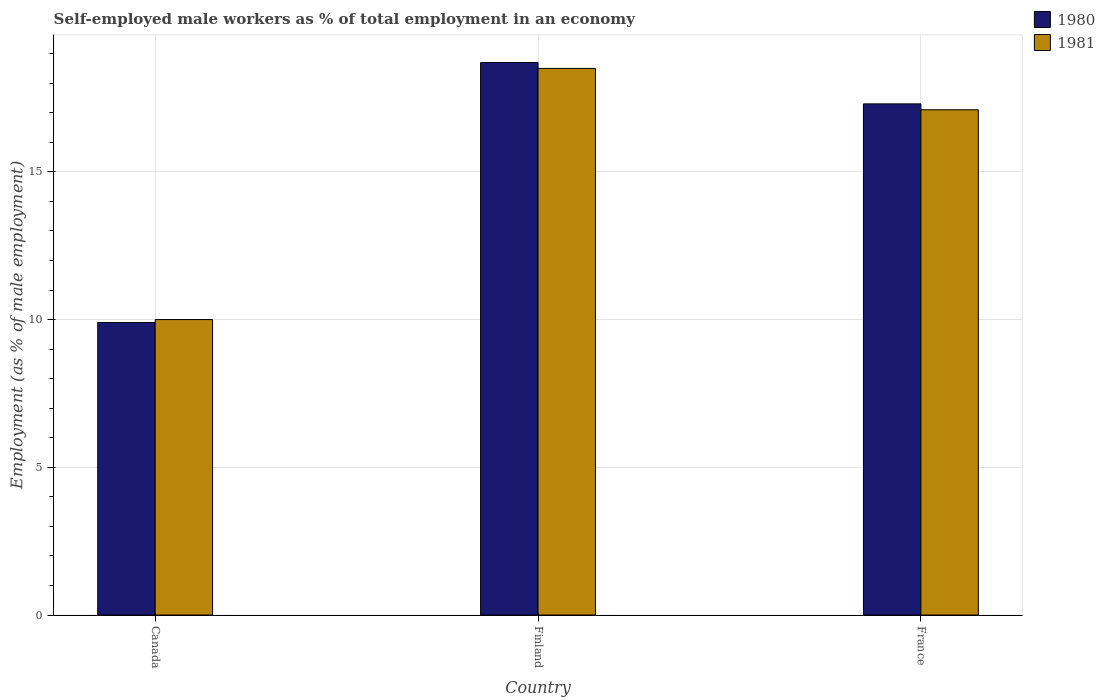How many groups of bars are there?
Make the answer very short. 3. Are the number of bars per tick equal to the number of legend labels?
Your response must be concise. Yes. Are the number of bars on each tick of the X-axis equal?
Your answer should be very brief. Yes. How many bars are there on the 2nd tick from the right?
Your answer should be very brief. 2. Across all countries, what is the minimum percentage of self-employed male workers in 1980?
Provide a succinct answer. 9.9. In which country was the percentage of self-employed male workers in 1980 maximum?
Provide a short and direct response. Finland. In which country was the percentage of self-employed male workers in 1981 minimum?
Make the answer very short. Canada. What is the total percentage of self-employed male workers in 1981 in the graph?
Your response must be concise. 45.6. What is the difference between the percentage of self-employed male workers in 1981 in Finland and that in France?
Your answer should be very brief. 1.4. What is the difference between the percentage of self-employed male workers in 1980 in France and the percentage of self-employed male workers in 1981 in Canada?
Give a very brief answer. 7.3. What is the average percentage of self-employed male workers in 1981 per country?
Offer a terse response. 15.2. What is the difference between the percentage of self-employed male workers of/in 1980 and percentage of self-employed male workers of/in 1981 in Canada?
Make the answer very short. -0.1. In how many countries, is the percentage of self-employed male workers in 1980 greater than 8 %?
Provide a succinct answer. 3. What is the ratio of the percentage of self-employed male workers in 1981 in Canada to that in France?
Your answer should be compact. 0.58. What is the difference between the highest and the second highest percentage of self-employed male workers in 1981?
Make the answer very short. -1.4. What is the difference between the highest and the lowest percentage of self-employed male workers in 1980?
Your answer should be very brief. 8.8. In how many countries, is the percentage of self-employed male workers in 1980 greater than the average percentage of self-employed male workers in 1980 taken over all countries?
Give a very brief answer. 2. Is the sum of the percentage of self-employed male workers in 1981 in Canada and France greater than the maximum percentage of self-employed male workers in 1980 across all countries?
Offer a very short reply. Yes. What does the 1st bar from the left in France represents?
Provide a short and direct response. 1980. What does the 2nd bar from the right in Canada represents?
Provide a short and direct response. 1980. How many bars are there?
Keep it short and to the point. 6. Are the values on the major ticks of Y-axis written in scientific E-notation?
Ensure brevity in your answer.  No. Where does the legend appear in the graph?
Offer a terse response. Top right. How many legend labels are there?
Make the answer very short. 2. What is the title of the graph?
Provide a succinct answer. Self-employed male workers as % of total employment in an economy. What is the label or title of the X-axis?
Your response must be concise. Country. What is the label or title of the Y-axis?
Offer a very short reply. Employment (as % of male employment). What is the Employment (as % of male employment) in 1980 in Canada?
Your answer should be very brief. 9.9. What is the Employment (as % of male employment) of 1981 in Canada?
Your response must be concise. 10. What is the Employment (as % of male employment) of 1980 in Finland?
Your response must be concise. 18.7. What is the Employment (as % of male employment) in 1980 in France?
Give a very brief answer. 17.3. What is the Employment (as % of male employment) in 1981 in France?
Your answer should be very brief. 17.1. Across all countries, what is the maximum Employment (as % of male employment) of 1980?
Give a very brief answer. 18.7. Across all countries, what is the maximum Employment (as % of male employment) of 1981?
Give a very brief answer. 18.5. Across all countries, what is the minimum Employment (as % of male employment) of 1980?
Make the answer very short. 9.9. What is the total Employment (as % of male employment) of 1980 in the graph?
Make the answer very short. 45.9. What is the total Employment (as % of male employment) of 1981 in the graph?
Offer a very short reply. 45.6. What is the difference between the Employment (as % of male employment) of 1981 in Canada and that in France?
Keep it short and to the point. -7.1. What is the difference between the Employment (as % of male employment) of 1980 in Finland and that in France?
Ensure brevity in your answer.  1.4. What is the difference between the Employment (as % of male employment) of 1980 in Canada and the Employment (as % of male employment) of 1981 in Finland?
Your response must be concise. -8.6. What is the difference between the Employment (as % of male employment) of 1980 in Canada and the Employment (as % of male employment) of 1981 in France?
Your answer should be compact. -7.2. What is the difference between the Employment (as % of male employment) in 1980 in Finland and the Employment (as % of male employment) in 1981 in France?
Keep it short and to the point. 1.6. What is the average Employment (as % of male employment) of 1980 per country?
Keep it short and to the point. 15.3. What is the difference between the Employment (as % of male employment) of 1980 and Employment (as % of male employment) of 1981 in France?
Keep it short and to the point. 0.2. What is the ratio of the Employment (as % of male employment) in 1980 in Canada to that in Finland?
Offer a terse response. 0.53. What is the ratio of the Employment (as % of male employment) in 1981 in Canada to that in Finland?
Give a very brief answer. 0.54. What is the ratio of the Employment (as % of male employment) in 1980 in Canada to that in France?
Your response must be concise. 0.57. What is the ratio of the Employment (as % of male employment) of 1981 in Canada to that in France?
Ensure brevity in your answer.  0.58. What is the ratio of the Employment (as % of male employment) of 1980 in Finland to that in France?
Your answer should be very brief. 1.08. What is the ratio of the Employment (as % of male employment) of 1981 in Finland to that in France?
Your answer should be compact. 1.08. What is the difference between the highest and the lowest Employment (as % of male employment) in 1980?
Offer a terse response. 8.8. 